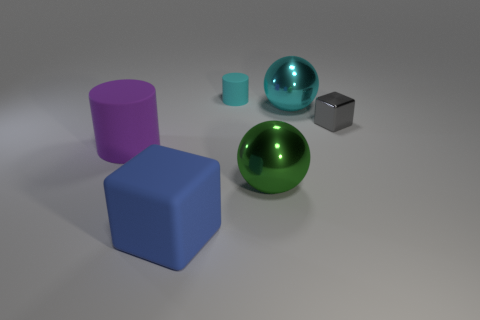There is a cube that is behind the large rubber object that is behind the big blue rubber cube that is in front of the tiny rubber object; how big is it?
Keep it short and to the point. Small. What is the shape of the cyan thing that is the same size as the purple object?
Offer a very short reply. Sphere. How many objects are cylinders on the right side of the big rubber cube or big objects?
Your answer should be very brief. 5. There is a cyan object in front of the matte cylinder that is right of the big blue matte block; are there any small gray cubes behind it?
Provide a succinct answer. No. How many purple things are there?
Make the answer very short. 1. How many things are either small gray things that are to the right of the cyan cylinder or small things that are on the right side of the tiny cyan matte thing?
Make the answer very short. 1. Do the matte object behind the metal cube and the cyan metal object have the same size?
Offer a terse response. No. There is another matte object that is the same shape as the tiny gray thing; what is its size?
Offer a terse response. Large. What material is the cyan sphere that is the same size as the purple rubber cylinder?
Ensure brevity in your answer.  Metal. There is a small thing that is the same shape as the large purple rubber thing; what material is it?
Make the answer very short. Rubber. 